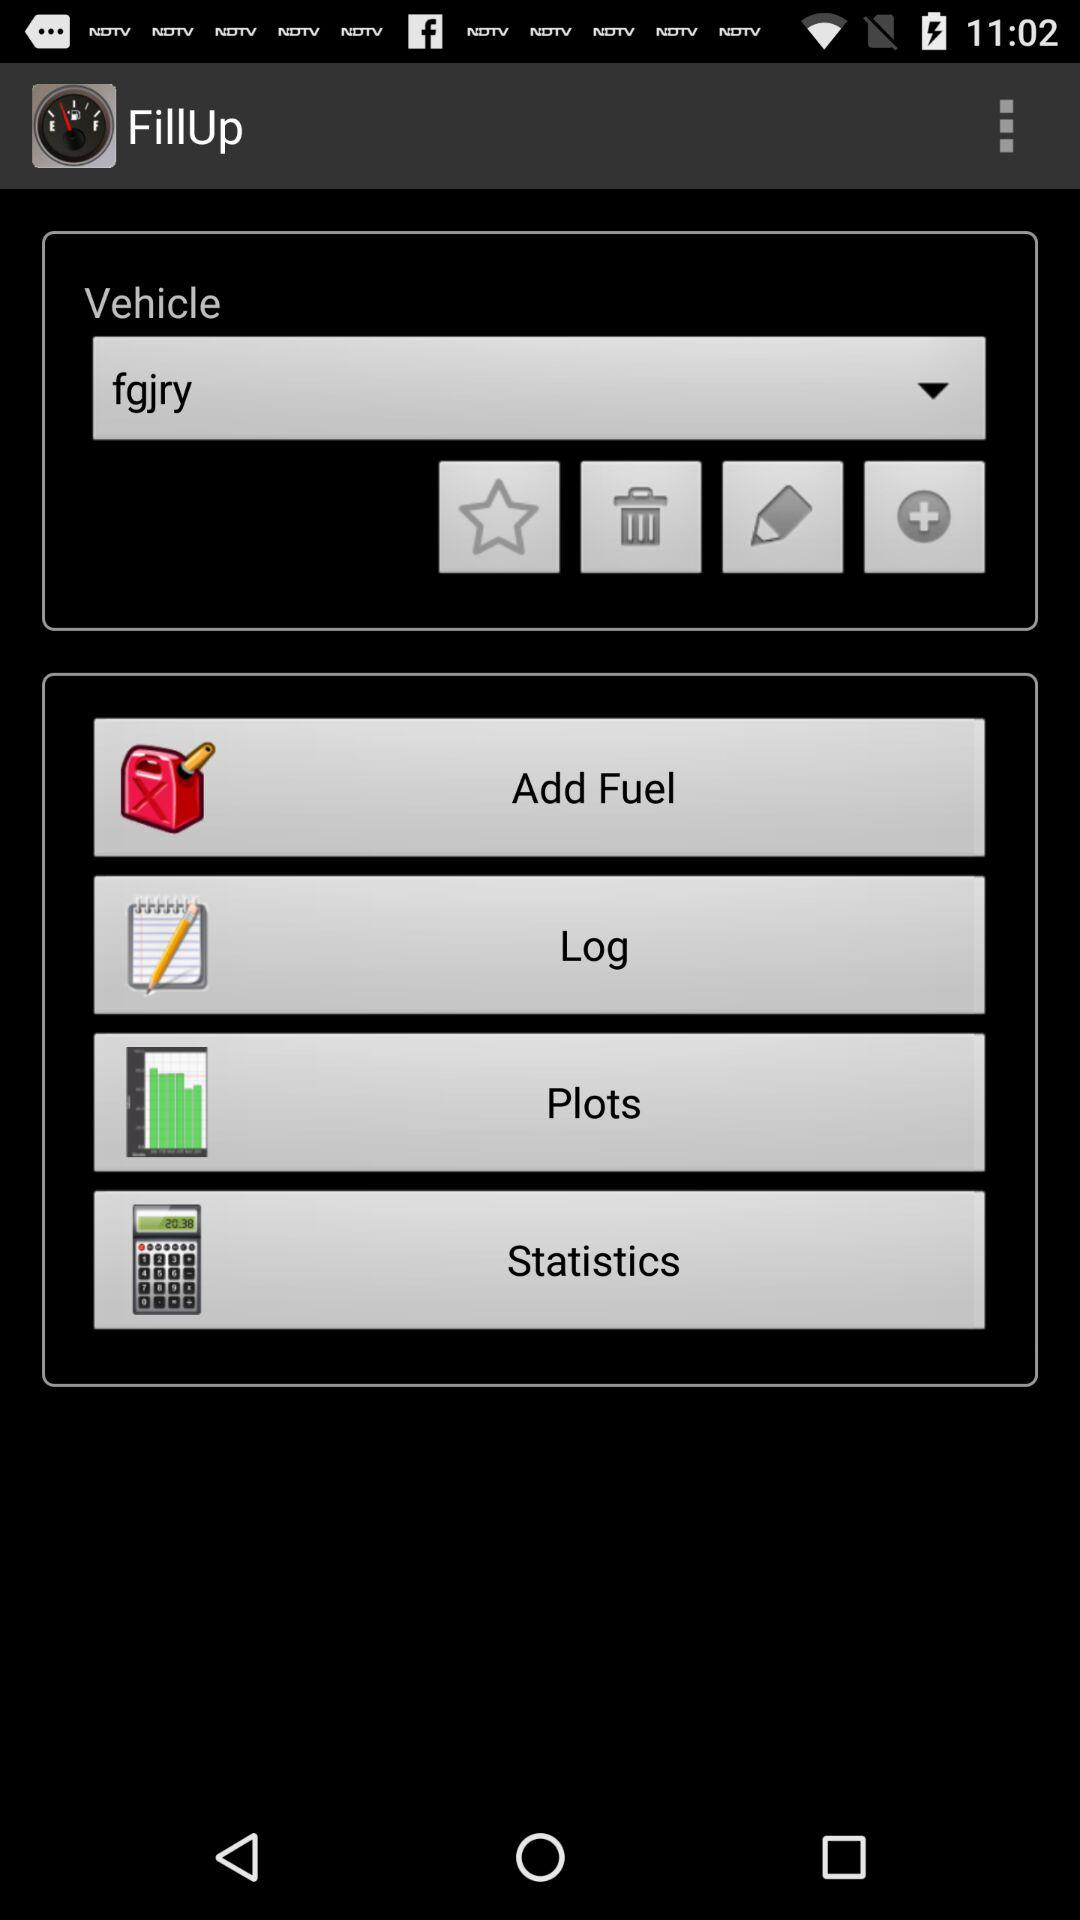What vehicle is selected? The selected vehicle is "fgjry". 